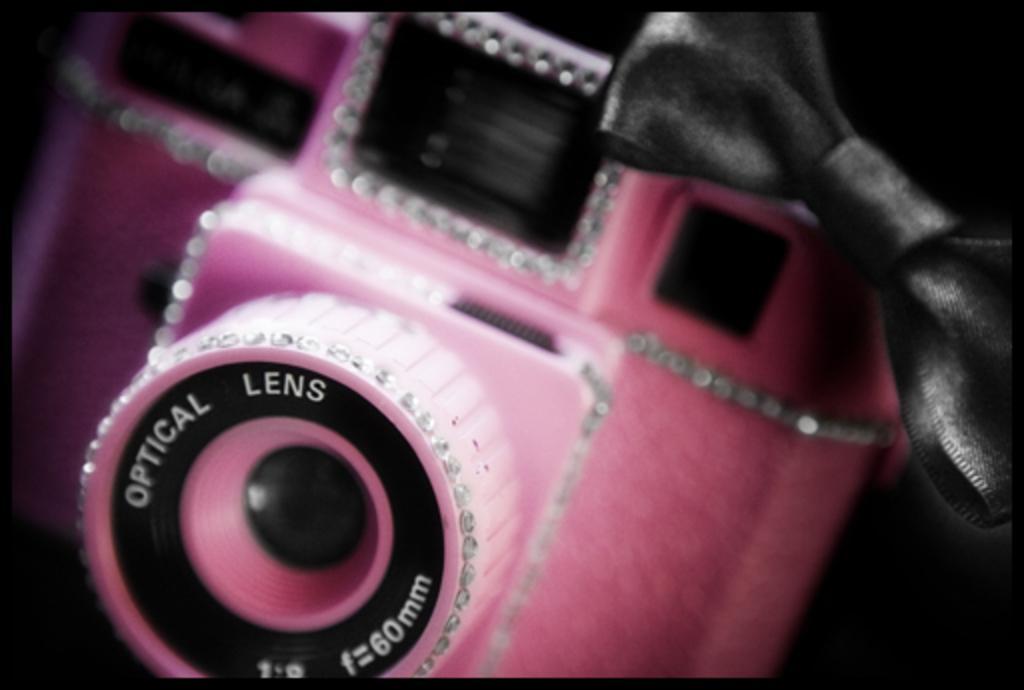Please provide a concise description of this image. In the image there is a pink color camera with a ribbon above it. 